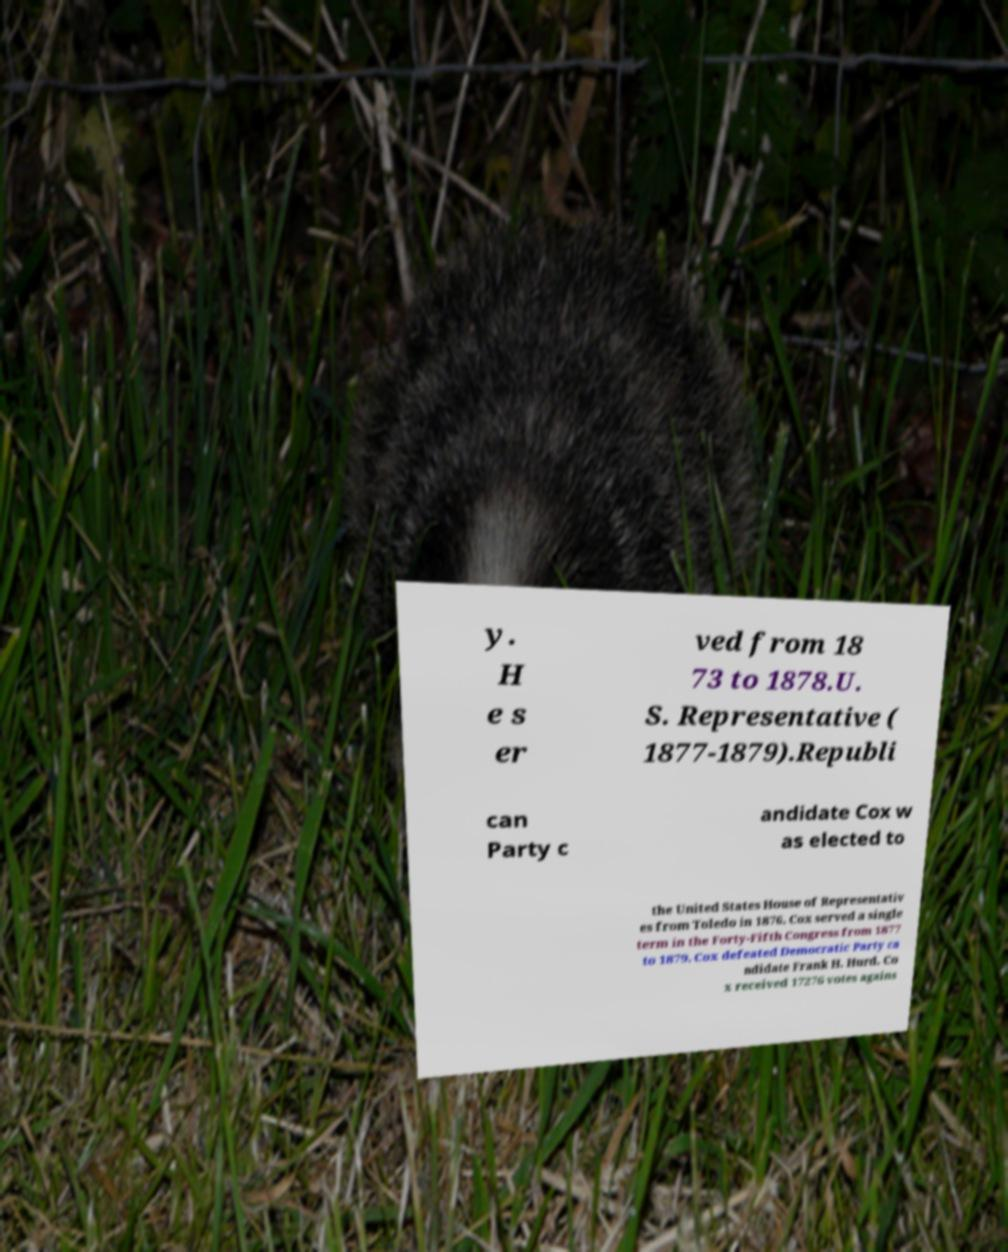Could you extract and type out the text from this image? y. H e s er ved from 18 73 to 1878.U. S. Representative ( 1877-1879).Republi can Party c andidate Cox w as elected to the United States House of Representativ es from Toledo in 1876. Cox served a single term in the Forty-Fifth Congress from 1877 to 1879. Cox defeated Democratic Party ca ndidate Frank H. Hurd. Co x received 17276 votes agains 